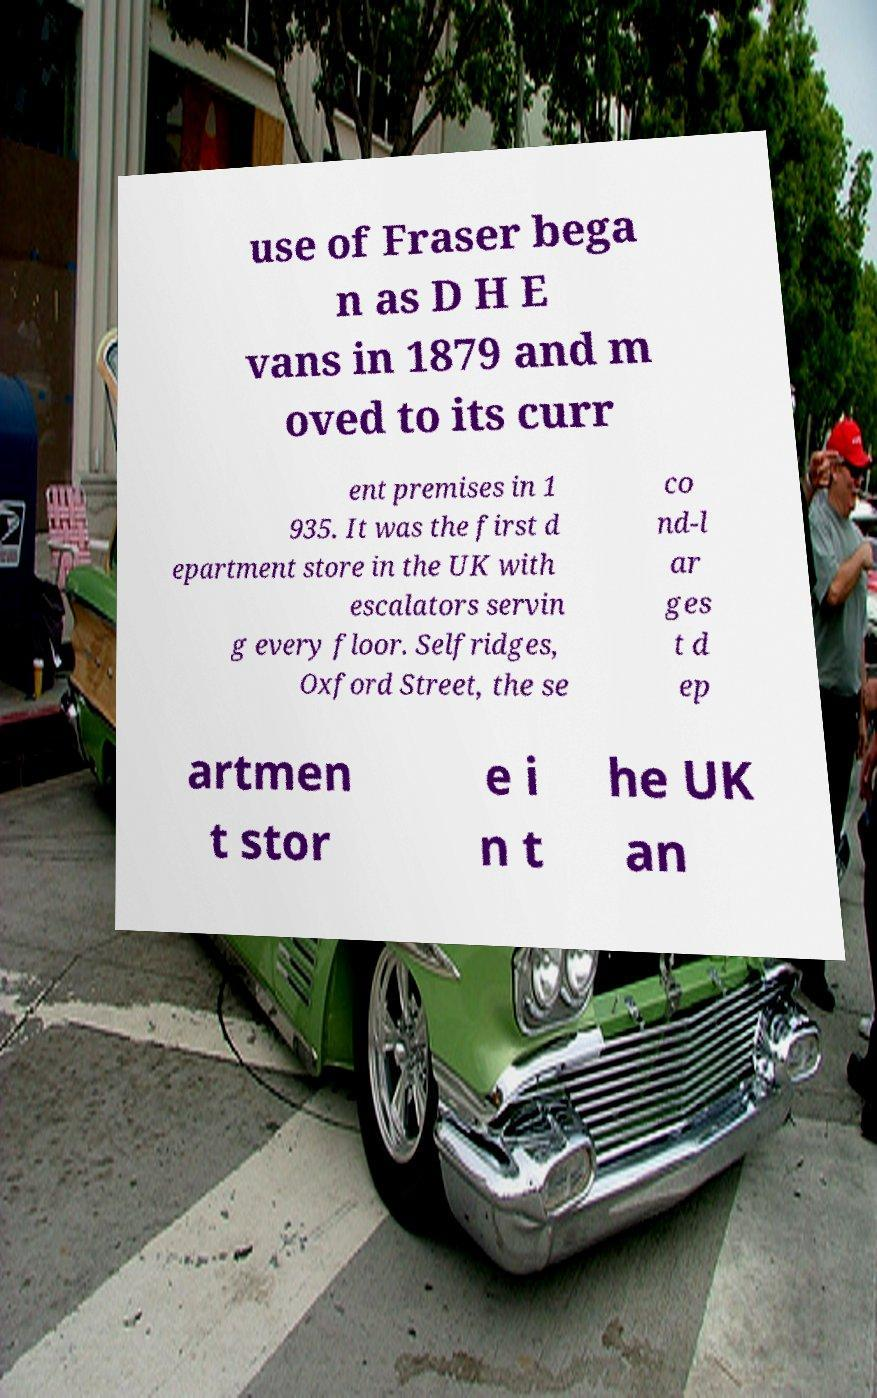Please identify and transcribe the text found in this image. use of Fraser bega n as D H E vans in 1879 and m oved to its curr ent premises in 1 935. It was the first d epartment store in the UK with escalators servin g every floor. Selfridges, Oxford Street, the se co nd-l ar ges t d ep artmen t stor e i n t he UK an 